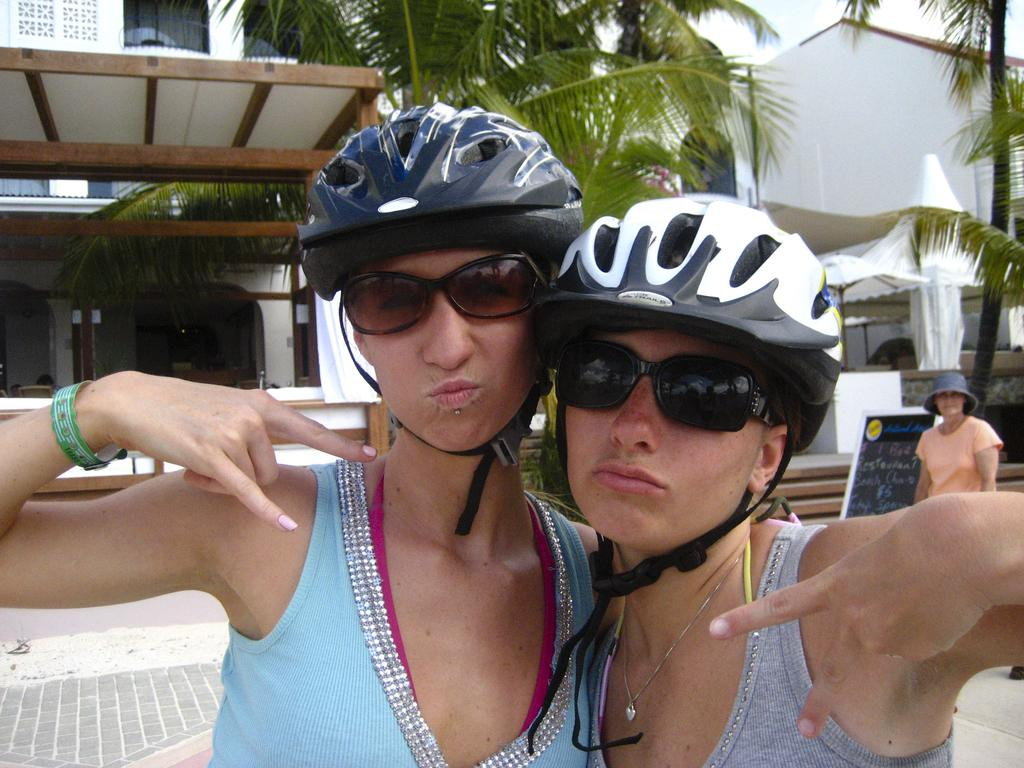How many people are present in the image? There are two persons standing in the image. What are the people wearing on their heads? The persons are wearing helmets. What type of natural element can be seen in the image? There is a tree in the image. What type of man-made structure is visible in the image? There is a building in the image. What is visible in the background of the image? The sky is visible in the image. What type of advertisement can be seen on the tree in the image? There is no advertisement present on the tree in the image; it is a natural element with no man-made additions. 